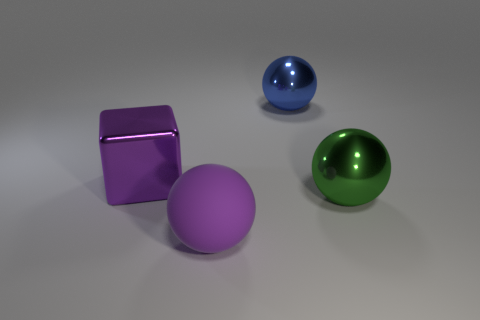Add 4 cyan cubes. How many objects exist? 8 Subtract all spheres. How many objects are left? 1 Add 1 tiny blue metal cylinders. How many tiny blue metal cylinders exist? 1 Subtract 1 purple cubes. How many objects are left? 3 Subtract all big purple metallic cubes. Subtract all green objects. How many objects are left? 2 Add 4 green balls. How many green balls are left? 5 